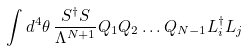<formula> <loc_0><loc_0><loc_500><loc_500>\int d ^ { 4 } \theta \, \frac { S ^ { \dag } S } { \Lambda ^ { N + 1 } } { Q _ { 1 } } { Q _ { 2 } } \dots Q _ { N - 1 } L _ { i } ^ { \dag } L _ { j }</formula> 